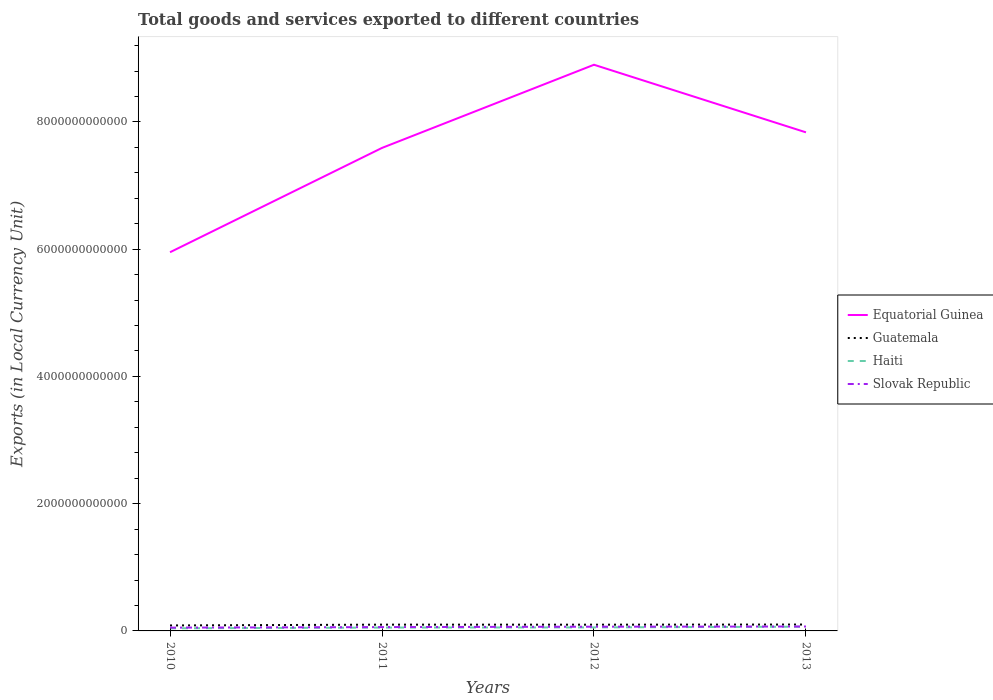Is the number of lines equal to the number of legend labels?
Keep it short and to the point. Yes. Across all years, what is the maximum Amount of goods and services exports in Guatemala?
Your answer should be compact. 8.60e+1. What is the total Amount of goods and services exports in Haiti in the graph?
Keep it short and to the point. -1.45e+1. What is the difference between the highest and the second highest Amount of goods and services exports in Equatorial Guinea?
Ensure brevity in your answer.  2.95e+12. Is the Amount of goods and services exports in Haiti strictly greater than the Amount of goods and services exports in Guatemala over the years?
Offer a very short reply. Yes. How many years are there in the graph?
Give a very brief answer. 4. What is the difference between two consecutive major ticks on the Y-axis?
Provide a short and direct response. 2.00e+12. Does the graph contain any zero values?
Make the answer very short. No. Where does the legend appear in the graph?
Your answer should be compact. Center right. How are the legend labels stacked?
Offer a terse response. Vertical. What is the title of the graph?
Keep it short and to the point. Total goods and services exported to different countries. Does "Ecuador" appear as one of the legend labels in the graph?
Ensure brevity in your answer.  No. What is the label or title of the X-axis?
Make the answer very short. Years. What is the label or title of the Y-axis?
Offer a very short reply. Exports (in Local Currency Unit). What is the Exports (in Local Currency Unit) in Equatorial Guinea in 2010?
Offer a very short reply. 5.95e+12. What is the Exports (in Local Currency Unit) of Guatemala in 2010?
Provide a succinct answer. 8.60e+1. What is the Exports (in Local Currency Unit) in Haiti in 2010?
Offer a terse response. 4.10e+1. What is the Exports (in Local Currency Unit) of Slovak Republic in 2010?
Your answer should be very brief. 5.16e+1. What is the Exports (in Local Currency Unit) of Equatorial Guinea in 2011?
Ensure brevity in your answer.  7.59e+12. What is the Exports (in Local Currency Unit) in Guatemala in 2011?
Give a very brief answer. 9.88e+1. What is the Exports (in Local Currency Unit) of Haiti in 2011?
Keep it short and to the point. 5.28e+1. What is the Exports (in Local Currency Unit) in Slovak Republic in 2011?
Provide a succinct answer. 6.01e+1. What is the Exports (in Local Currency Unit) of Equatorial Guinea in 2012?
Your answer should be compact. 8.90e+12. What is the Exports (in Local Currency Unit) of Guatemala in 2012?
Offer a very short reply. 9.82e+1. What is the Exports (in Local Currency Unit) of Haiti in 2012?
Your answer should be compact. 5.55e+1. What is the Exports (in Local Currency Unit) in Slovak Republic in 2012?
Offer a terse response. 6.65e+1. What is the Exports (in Local Currency Unit) in Equatorial Guinea in 2013?
Offer a very short reply. 7.84e+12. What is the Exports (in Local Currency Unit) of Guatemala in 2013?
Your response must be concise. 1.00e+11. What is the Exports (in Local Currency Unit) of Haiti in 2013?
Your answer should be compact. 6.65e+1. What is the Exports (in Local Currency Unit) in Slovak Republic in 2013?
Offer a terse response. 6.93e+1. Across all years, what is the maximum Exports (in Local Currency Unit) of Equatorial Guinea?
Provide a short and direct response. 8.90e+12. Across all years, what is the maximum Exports (in Local Currency Unit) in Guatemala?
Make the answer very short. 1.00e+11. Across all years, what is the maximum Exports (in Local Currency Unit) of Haiti?
Provide a short and direct response. 6.65e+1. Across all years, what is the maximum Exports (in Local Currency Unit) of Slovak Republic?
Provide a short and direct response. 6.93e+1. Across all years, what is the minimum Exports (in Local Currency Unit) in Equatorial Guinea?
Make the answer very short. 5.95e+12. Across all years, what is the minimum Exports (in Local Currency Unit) of Guatemala?
Keep it short and to the point. 8.60e+1. Across all years, what is the minimum Exports (in Local Currency Unit) of Haiti?
Give a very brief answer. 4.10e+1. Across all years, what is the minimum Exports (in Local Currency Unit) in Slovak Republic?
Provide a succinct answer. 5.16e+1. What is the total Exports (in Local Currency Unit) of Equatorial Guinea in the graph?
Keep it short and to the point. 3.03e+13. What is the total Exports (in Local Currency Unit) of Guatemala in the graph?
Keep it short and to the point. 3.83e+11. What is the total Exports (in Local Currency Unit) of Haiti in the graph?
Your response must be concise. 2.16e+11. What is the total Exports (in Local Currency Unit) in Slovak Republic in the graph?
Keep it short and to the point. 2.47e+11. What is the difference between the Exports (in Local Currency Unit) in Equatorial Guinea in 2010 and that in 2011?
Give a very brief answer. -1.64e+12. What is the difference between the Exports (in Local Currency Unit) in Guatemala in 2010 and that in 2011?
Make the answer very short. -1.28e+1. What is the difference between the Exports (in Local Currency Unit) of Haiti in 2010 and that in 2011?
Provide a succinct answer. -1.19e+1. What is the difference between the Exports (in Local Currency Unit) of Slovak Republic in 2010 and that in 2011?
Provide a succinct answer. -8.48e+09. What is the difference between the Exports (in Local Currency Unit) of Equatorial Guinea in 2010 and that in 2012?
Offer a terse response. -2.95e+12. What is the difference between the Exports (in Local Currency Unit) in Guatemala in 2010 and that in 2012?
Provide a short and direct response. -1.22e+1. What is the difference between the Exports (in Local Currency Unit) of Haiti in 2010 and that in 2012?
Provide a short and direct response. -1.45e+1. What is the difference between the Exports (in Local Currency Unit) of Slovak Republic in 2010 and that in 2012?
Your response must be concise. -1.49e+1. What is the difference between the Exports (in Local Currency Unit) in Equatorial Guinea in 2010 and that in 2013?
Ensure brevity in your answer.  -1.88e+12. What is the difference between the Exports (in Local Currency Unit) in Guatemala in 2010 and that in 2013?
Your answer should be compact. -1.44e+1. What is the difference between the Exports (in Local Currency Unit) in Haiti in 2010 and that in 2013?
Your answer should be compact. -2.56e+1. What is the difference between the Exports (in Local Currency Unit) of Slovak Republic in 2010 and that in 2013?
Make the answer very short. -1.77e+1. What is the difference between the Exports (in Local Currency Unit) of Equatorial Guinea in 2011 and that in 2012?
Your response must be concise. -1.31e+12. What is the difference between the Exports (in Local Currency Unit) of Guatemala in 2011 and that in 2012?
Your response must be concise. 6.21e+08. What is the difference between the Exports (in Local Currency Unit) of Haiti in 2011 and that in 2012?
Provide a short and direct response. -2.62e+09. What is the difference between the Exports (in Local Currency Unit) of Slovak Republic in 2011 and that in 2012?
Offer a very short reply. -6.41e+09. What is the difference between the Exports (in Local Currency Unit) of Equatorial Guinea in 2011 and that in 2013?
Offer a terse response. -2.45e+11. What is the difference between the Exports (in Local Currency Unit) of Guatemala in 2011 and that in 2013?
Offer a very short reply. -1.57e+09. What is the difference between the Exports (in Local Currency Unit) of Haiti in 2011 and that in 2013?
Ensure brevity in your answer.  -1.37e+1. What is the difference between the Exports (in Local Currency Unit) in Slovak Republic in 2011 and that in 2013?
Your answer should be very brief. -9.22e+09. What is the difference between the Exports (in Local Currency Unit) in Equatorial Guinea in 2012 and that in 2013?
Give a very brief answer. 1.06e+12. What is the difference between the Exports (in Local Currency Unit) of Guatemala in 2012 and that in 2013?
Ensure brevity in your answer.  -2.19e+09. What is the difference between the Exports (in Local Currency Unit) of Haiti in 2012 and that in 2013?
Make the answer very short. -1.11e+1. What is the difference between the Exports (in Local Currency Unit) in Slovak Republic in 2012 and that in 2013?
Make the answer very short. -2.81e+09. What is the difference between the Exports (in Local Currency Unit) of Equatorial Guinea in 2010 and the Exports (in Local Currency Unit) of Guatemala in 2011?
Keep it short and to the point. 5.85e+12. What is the difference between the Exports (in Local Currency Unit) in Equatorial Guinea in 2010 and the Exports (in Local Currency Unit) in Haiti in 2011?
Offer a very short reply. 5.90e+12. What is the difference between the Exports (in Local Currency Unit) in Equatorial Guinea in 2010 and the Exports (in Local Currency Unit) in Slovak Republic in 2011?
Make the answer very short. 5.89e+12. What is the difference between the Exports (in Local Currency Unit) in Guatemala in 2010 and the Exports (in Local Currency Unit) in Haiti in 2011?
Provide a short and direct response. 3.31e+1. What is the difference between the Exports (in Local Currency Unit) in Guatemala in 2010 and the Exports (in Local Currency Unit) in Slovak Republic in 2011?
Provide a succinct answer. 2.59e+1. What is the difference between the Exports (in Local Currency Unit) of Haiti in 2010 and the Exports (in Local Currency Unit) of Slovak Republic in 2011?
Your response must be concise. -1.91e+1. What is the difference between the Exports (in Local Currency Unit) in Equatorial Guinea in 2010 and the Exports (in Local Currency Unit) in Guatemala in 2012?
Your response must be concise. 5.85e+12. What is the difference between the Exports (in Local Currency Unit) in Equatorial Guinea in 2010 and the Exports (in Local Currency Unit) in Haiti in 2012?
Offer a terse response. 5.90e+12. What is the difference between the Exports (in Local Currency Unit) in Equatorial Guinea in 2010 and the Exports (in Local Currency Unit) in Slovak Republic in 2012?
Your response must be concise. 5.89e+12. What is the difference between the Exports (in Local Currency Unit) of Guatemala in 2010 and the Exports (in Local Currency Unit) of Haiti in 2012?
Provide a short and direct response. 3.05e+1. What is the difference between the Exports (in Local Currency Unit) in Guatemala in 2010 and the Exports (in Local Currency Unit) in Slovak Republic in 2012?
Give a very brief answer. 1.95e+1. What is the difference between the Exports (in Local Currency Unit) of Haiti in 2010 and the Exports (in Local Currency Unit) of Slovak Republic in 2012?
Ensure brevity in your answer.  -2.55e+1. What is the difference between the Exports (in Local Currency Unit) in Equatorial Guinea in 2010 and the Exports (in Local Currency Unit) in Guatemala in 2013?
Provide a short and direct response. 5.85e+12. What is the difference between the Exports (in Local Currency Unit) in Equatorial Guinea in 2010 and the Exports (in Local Currency Unit) in Haiti in 2013?
Provide a short and direct response. 5.89e+12. What is the difference between the Exports (in Local Currency Unit) of Equatorial Guinea in 2010 and the Exports (in Local Currency Unit) of Slovak Republic in 2013?
Your response must be concise. 5.88e+12. What is the difference between the Exports (in Local Currency Unit) in Guatemala in 2010 and the Exports (in Local Currency Unit) in Haiti in 2013?
Provide a succinct answer. 1.94e+1. What is the difference between the Exports (in Local Currency Unit) in Guatemala in 2010 and the Exports (in Local Currency Unit) in Slovak Republic in 2013?
Provide a succinct answer. 1.67e+1. What is the difference between the Exports (in Local Currency Unit) of Haiti in 2010 and the Exports (in Local Currency Unit) of Slovak Republic in 2013?
Offer a terse response. -2.83e+1. What is the difference between the Exports (in Local Currency Unit) of Equatorial Guinea in 2011 and the Exports (in Local Currency Unit) of Guatemala in 2012?
Make the answer very short. 7.49e+12. What is the difference between the Exports (in Local Currency Unit) of Equatorial Guinea in 2011 and the Exports (in Local Currency Unit) of Haiti in 2012?
Provide a succinct answer. 7.54e+12. What is the difference between the Exports (in Local Currency Unit) in Equatorial Guinea in 2011 and the Exports (in Local Currency Unit) in Slovak Republic in 2012?
Offer a terse response. 7.52e+12. What is the difference between the Exports (in Local Currency Unit) of Guatemala in 2011 and the Exports (in Local Currency Unit) of Haiti in 2012?
Your answer should be very brief. 4.33e+1. What is the difference between the Exports (in Local Currency Unit) of Guatemala in 2011 and the Exports (in Local Currency Unit) of Slovak Republic in 2012?
Keep it short and to the point. 3.23e+1. What is the difference between the Exports (in Local Currency Unit) of Haiti in 2011 and the Exports (in Local Currency Unit) of Slovak Republic in 2012?
Your response must be concise. -1.36e+1. What is the difference between the Exports (in Local Currency Unit) in Equatorial Guinea in 2011 and the Exports (in Local Currency Unit) in Guatemala in 2013?
Provide a succinct answer. 7.49e+12. What is the difference between the Exports (in Local Currency Unit) in Equatorial Guinea in 2011 and the Exports (in Local Currency Unit) in Haiti in 2013?
Your answer should be very brief. 7.52e+12. What is the difference between the Exports (in Local Currency Unit) of Equatorial Guinea in 2011 and the Exports (in Local Currency Unit) of Slovak Republic in 2013?
Ensure brevity in your answer.  7.52e+12. What is the difference between the Exports (in Local Currency Unit) of Guatemala in 2011 and the Exports (in Local Currency Unit) of Haiti in 2013?
Make the answer very short. 3.22e+1. What is the difference between the Exports (in Local Currency Unit) in Guatemala in 2011 and the Exports (in Local Currency Unit) in Slovak Republic in 2013?
Keep it short and to the point. 2.95e+1. What is the difference between the Exports (in Local Currency Unit) in Haiti in 2011 and the Exports (in Local Currency Unit) in Slovak Republic in 2013?
Make the answer very short. -1.64e+1. What is the difference between the Exports (in Local Currency Unit) of Equatorial Guinea in 2012 and the Exports (in Local Currency Unit) of Guatemala in 2013?
Keep it short and to the point. 8.80e+12. What is the difference between the Exports (in Local Currency Unit) of Equatorial Guinea in 2012 and the Exports (in Local Currency Unit) of Haiti in 2013?
Make the answer very short. 8.83e+12. What is the difference between the Exports (in Local Currency Unit) of Equatorial Guinea in 2012 and the Exports (in Local Currency Unit) of Slovak Republic in 2013?
Make the answer very short. 8.83e+12. What is the difference between the Exports (in Local Currency Unit) in Guatemala in 2012 and the Exports (in Local Currency Unit) in Haiti in 2013?
Offer a terse response. 3.16e+1. What is the difference between the Exports (in Local Currency Unit) in Guatemala in 2012 and the Exports (in Local Currency Unit) in Slovak Republic in 2013?
Make the answer very short. 2.89e+1. What is the difference between the Exports (in Local Currency Unit) in Haiti in 2012 and the Exports (in Local Currency Unit) in Slovak Republic in 2013?
Keep it short and to the point. -1.38e+1. What is the average Exports (in Local Currency Unit) in Equatorial Guinea per year?
Make the answer very short. 7.57e+12. What is the average Exports (in Local Currency Unit) in Guatemala per year?
Your response must be concise. 9.58e+1. What is the average Exports (in Local Currency Unit) in Haiti per year?
Provide a short and direct response. 5.40e+1. What is the average Exports (in Local Currency Unit) of Slovak Republic per year?
Provide a succinct answer. 6.19e+1. In the year 2010, what is the difference between the Exports (in Local Currency Unit) of Equatorial Guinea and Exports (in Local Currency Unit) of Guatemala?
Make the answer very short. 5.87e+12. In the year 2010, what is the difference between the Exports (in Local Currency Unit) in Equatorial Guinea and Exports (in Local Currency Unit) in Haiti?
Offer a very short reply. 5.91e+12. In the year 2010, what is the difference between the Exports (in Local Currency Unit) in Equatorial Guinea and Exports (in Local Currency Unit) in Slovak Republic?
Make the answer very short. 5.90e+12. In the year 2010, what is the difference between the Exports (in Local Currency Unit) in Guatemala and Exports (in Local Currency Unit) in Haiti?
Make the answer very short. 4.50e+1. In the year 2010, what is the difference between the Exports (in Local Currency Unit) in Guatemala and Exports (in Local Currency Unit) in Slovak Republic?
Your response must be concise. 3.44e+1. In the year 2010, what is the difference between the Exports (in Local Currency Unit) of Haiti and Exports (in Local Currency Unit) of Slovak Republic?
Provide a succinct answer. -1.06e+1. In the year 2011, what is the difference between the Exports (in Local Currency Unit) in Equatorial Guinea and Exports (in Local Currency Unit) in Guatemala?
Provide a succinct answer. 7.49e+12. In the year 2011, what is the difference between the Exports (in Local Currency Unit) in Equatorial Guinea and Exports (in Local Currency Unit) in Haiti?
Provide a short and direct response. 7.54e+12. In the year 2011, what is the difference between the Exports (in Local Currency Unit) in Equatorial Guinea and Exports (in Local Currency Unit) in Slovak Republic?
Your answer should be compact. 7.53e+12. In the year 2011, what is the difference between the Exports (in Local Currency Unit) of Guatemala and Exports (in Local Currency Unit) of Haiti?
Keep it short and to the point. 4.59e+1. In the year 2011, what is the difference between the Exports (in Local Currency Unit) in Guatemala and Exports (in Local Currency Unit) in Slovak Republic?
Keep it short and to the point. 3.87e+1. In the year 2011, what is the difference between the Exports (in Local Currency Unit) in Haiti and Exports (in Local Currency Unit) in Slovak Republic?
Offer a terse response. -7.22e+09. In the year 2012, what is the difference between the Exports (in Local Currency Unit) of Equatorial Guinea and Exports (in Local Currency Unit) of Guatemala?
Your response must be concise. 8.80e+12. In the year 2012, what is the difference between the Exports (in Local Currency Unit) in Equatorial Guinea and Exports (in Local Currency Unit) in Haiti?
Your answer should be very brief. 8.84e+12. In the year 2012, what is the difference between the Exports (in Local Currency Unit) of Equatorial Guinea and Exports (in Local Currency Unit) of Slovak Republic?
Your answer should be compact. 8.83e+12. In the year 2012, what is the difference between the Exports (in Local Currency Unit) in Guatemala and Exports (in Local Currency Unit) in Haiti?
Provide a short and direct response. 4.27e+1. In the year 2012, what is the difference between the Exports (in Local Currency Unit) in Guatemala and Exports (in Local Currency Unit) in Slovak Republic?
Make the answer very short. 3.17e+1. In the year 2012, what is the difference between the Exports (in Local Currency Unit) of Haiti and Exports (in Local Currency Unit) of Slovak Republic?
Keep it short and to the point. -1.10e+1. In the year 2013, what is the difference between the Exports (in Local Currency Unit) in Equatorial Guinea and Exports (in Local Currency Unit) in Guatemala?
Ensure brevity in your answer.  7.74e+12. In the year 2013, what is the difference between the Exports (in Local Currency Unit) of Equatorial Guinea and Exports (in Local Currency Unit) of Haiti?
Offer a very short reply. 7.77e+12. In the year 2013, what is the difference between the Exports (in Local Currency Unit) in Equatorial Guinea and Exports (in Local Currency Unit) in Slovak Republic?
Your response must be concise. 7.77e+12. In the year 2013, what is the difference between the Exports (in Local Currency Unit) of Guatemala and Exports (in Local Currency Unit) of Haiti?
Provide a short and direct response. 3.38e+1. In the year 2013, what is the difference between the Exports (in Local Currency Unit) of Guatemala and Exports (in Local Currency Unit) of Slovak Republic?
Provide a short and direct response. 3.11e+1. In the year 2013, what is the difference between the Exports (in Local Currency Unit) in Haiti and Exports (in Local Currency Unit) in Slovak Republic?
Provide a short and direct response. -2.74e+09. What is the ratio of the Exports (in Local Currency Unit) of Equatorial Guinea in 2010 to that in 2011?
Your answer should be very brief. 0.78. What is the ratio of the Exports (in Local Currency Unit) of Guatemala in 2010 to that in 2011?
Your answer should be compact. 0.87. What is the ratio of the Exports (in Local Currency Unit) in Haiti in 2010 to that in 2011?
Provide a succinct answer. 0.78. What is the ratio of the Exports (in Local Currency Unit) in Slovak Republic in 2010 to that in 2011?
Keep it short and to the point. 0.86. What is the ratio of the Exports (in Local Currency Unit) of Equatorial Guinea in 2010 to that in 2012?
Give a very brief answer. 0.67. What is the ratio of the Exports (in Local Currency Unit) of Guatemala in 2010 to that in 2012?
Make the answer very short. 0.88. What is the ratio of the Exports (in Local Currency Unit) of Haiti in 2010 to that in 2012?
Offer a very short reply. 0.74. What is the ratio of the Exports (in Local Currency Unit) in Slovak Republic in 2010 to that in 2012?
Your answer should be compact. 0.78. What is the ratio of the Exports (in Local Currency Unit) in Equatorial Guinea in 2010 to that in 2013?
Give a very brief answer. 0.76. What is the ratio of the Exports (in Local Currency Unit) of Guatemala in 2010 to that in 2013?
Your answer should be compact. 0.86. What is the ratio of the Exports (in Local Currency Unit) of Haiti in 2010 to that in 2013?
Your answer should be compact. 0.62. What is the ratio of the Exports (in Local Currency Unit) in Slovak Republic in 2010 to that in 2013?
Provide a short and direct response. 0.74. What is the ratio of the Exports (in Local Currency Unit) of Equatorial Guinea in 2011 to that in 2012?
Your response must be concise. 0.85. What is the ratio of the Exports (in Local Currency Unit) in Guatemala in 2011 to that in 2012?
Your response must be concise. 1.01. What is the ratio of the Exports (in Local Currency Unit) in Haiti in 2011 to that in 2012?
Give a very brief answer. 0.95. What is the ratio of the Exports (in Local Currency Unit) in Slovak Republic in 2011 to that in 2012?
Ensure brevity in your answer.  0.9. What is the ratio of the Exports (in Local Currency Unit) in Equatorial Guinea in 2011 to that in 2013?
Your response must be concise. 0.97. What is the ratio of the Exports (in Local Currency Unit) in Guatemala in 2011 to that in 2013?
Ensure brevity in your answer.  0.98. What is the ratio of the Exports (in Local Currency Unit) in Haiti in 2011 to that in 2013?
Offer a very short reply. 0.79. What is the ratio of the Exports (in Local Currency Unit) of Slovak Republic in 2011 to that in 2013?
Your answer should be compact. 0.87. What is the ratio of the Exports (in Local Currency Unit) of Equatorial Guinea in 2012 to that in 2013?
Ensure brevity in your answer.  1.14. What is the ratio of the Exports (in Local Currency Unit) of Guatemala in 2012 to that in 2013?
Your answer should be very brief. 0.98. What is the ratio of the Exports (in Local Currency Unit) of Haiti in 2012 to that in 2013?
Ensure brevity in your answer.  0.83. What is the ratio of the Exports (in Local Currency Unit) in Slovak Republic in 2012 to that in 2013?
Offer a very short reply. 0.96. What is the difference between the highest and the second highest Exports (in Local Currency Unit) in Equatorial Guinea?
Provide a succinct answer. 1.06e+12. What is the difference between the highest and the second highest Exports (in Local Currency Unit) of Guatemala?
Make the answer very short. 1.57e+09. What is the difference between the highest and the second highest Exports (in Local Currency Unit) of Haiti?
Your response must be concise. 1.11e+1. What is the difference between the highest and the second highest Exports (in Local Currency Unit) of Slovak Republic?
Offer a terse response. 2.81e+09. What is the difference between the highest and the lowest Exports (in Local Currency Unit) in Equatorial Guinea?
Your response must be concise. 2.95e+12. What is the difference between the highest and the lowest Exports (in Local Currency Unit) in Guatemala?
Provide a succinct answer. 1.44e+1. What is the difference between the highest and the lowest Exports (in Local Currency Unit) of Haiti?
Your answer should be compact. 2.56e+1. What is the difference between the highest and the lowest Exports (in Local Currency Unit) of Slovak Republic?
Offer a terse response. 1.77e+1. 